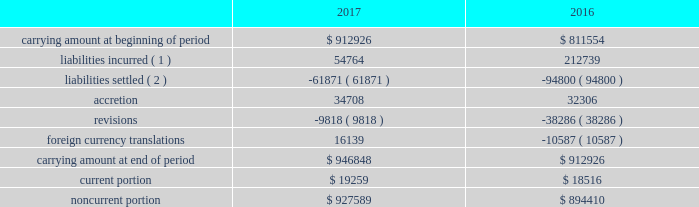14 .
Accounting for certain long-lived assets eog reviews its proved oil and gas properties for impairment purposes by comparing the expected undiscounted future cash flows at a depreciation , depletion and amortization group level to the unamortized capitalized cost of the asset .
The carrying rr values for assets determined to be impaired were adjusted to estimated fair value using the income approach described in the fair value measurement topic of the asc .
In certain instances , eog utilizes accepted offers from third-party purchasers as the basis for determining fair value .
During 2017 , proved oil and gas properties with a carrying amount of $ 370 million were written down to their fair value of $ 146 million , resulting in pretax impairment charges of $ 224 million .
During 2016 , proved oil and gas properties with a carrying rr amount of $ 643 million were written down to their fair value of $ 527 million , resulting in pretax impairment charges of $ 116 million .
Impairments in 2017 , 2016 and 2015 included domestic legacy natural gas assets .
Amortization and impairments of unproved oil and gas property costs , including amortization of capitalized interest , were $ 211 million , $ 291 million and $ 288 million during 2017 , 2016 and 2015 , respectively .
15 .
Asset retirement obligations the table presents the reconciliation of the beginning and ending aggregate carrying amounts of short-term and long-term legal obligations associated with the retirement of property , plant and equipment for the years ended december 31 , 2017 and 2016 ( in thousands ) : .
( 1 ) includes $ 164 million in 2016 related to yates transaction ( see note 17 ) .
( 2 ) includes settlements related to asset sales .
The current and noncurrent portions of eog's asset retirement obligations are included in current liabilities - other and other liabilities , respectively , on the consolidated balance sheets. .
Considering the years 2016 and 2017 , what is the average current portion? 
Rationale: it is the sum of both current portion's value divided by two .
Computations: table_average(current portion, none)
Answer: 18887.5. 